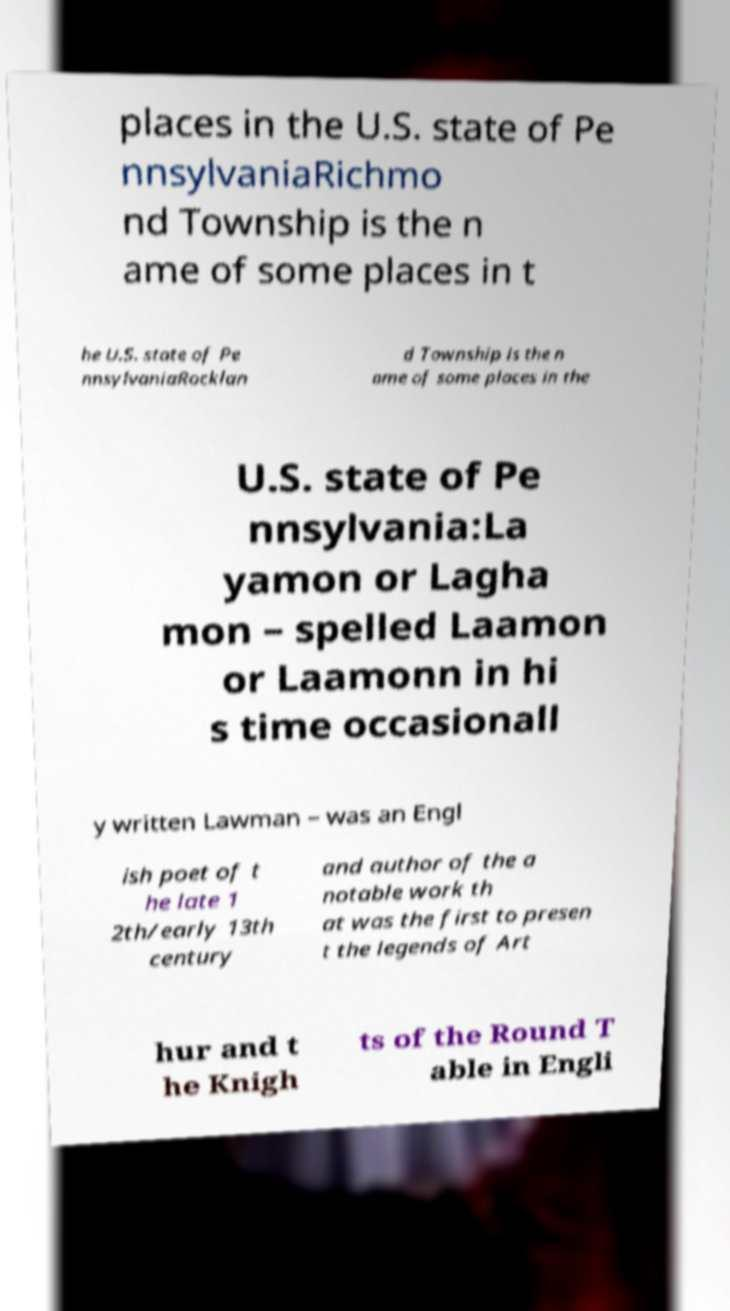Could you assist in decoding the text presented in this image and type it out clearly? places in the U.S. state of Pe nnsylvaniaRichmo nd Township is the n ame of some places in t he U.S. state of Pe nnsylvaniaRocklan d Township is the n ame of some places in the U.S. state of Pe nnsylvania:La yamon or Lagha mon – spelled Laamon or Laamonn in hi s time occasionall y written Lawman – was an Engl ish poet of t he late 1 2th/early 13th century and author of the a notable work th at was the first to presen t the legends of Art hur and t he Knigh ts of the Round T able in Engli 